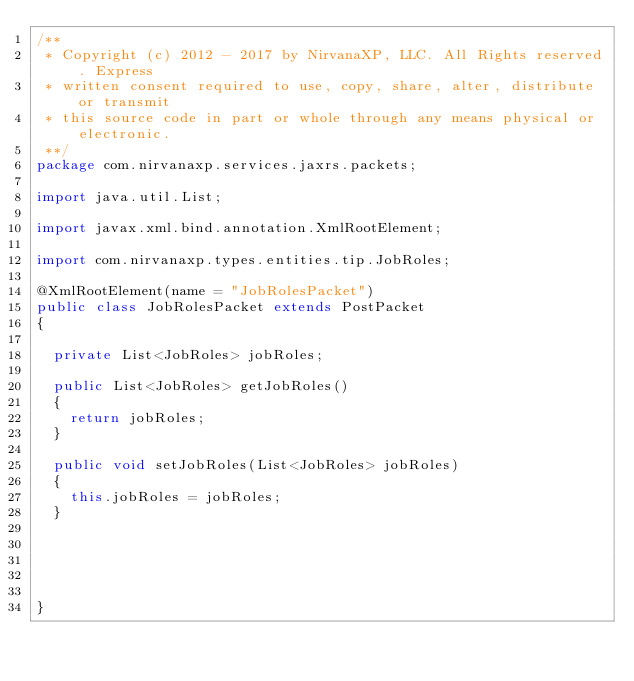Convert code to text. <code><loc_0><loc_0><loc_500><loc_500><_Java_>/**
 * Copyright (c) 2012 - 2017 by NirvanaXP, LLC. All Rights reserved. Express
 * written consent required to use, copy, share, alter, distribute or transmit
 * this source code in part or whole through any means physical or electronic.
 **/
package com.nirvanaxp.services.jaxrs.packets;

import java.util.List;

import javax.xml.bind.annotation.XmlRootElement;

import com.nirvanaxp.types.entities.tip.JobRoles;

@XmlRootElement(name = "JobRolesPacket")
public class JobRolesPacket extends PostPacket
{

	private List<JobRoles> jobRoles;

	public List<JobRoles> getJobRoles()
	{
		return jobRoles;
	}

	public void setJobRoles(List<JobRoles> jobRoles)
	{
		this.jobRoles = jobRoles;
	}

	

	

}
</code> 